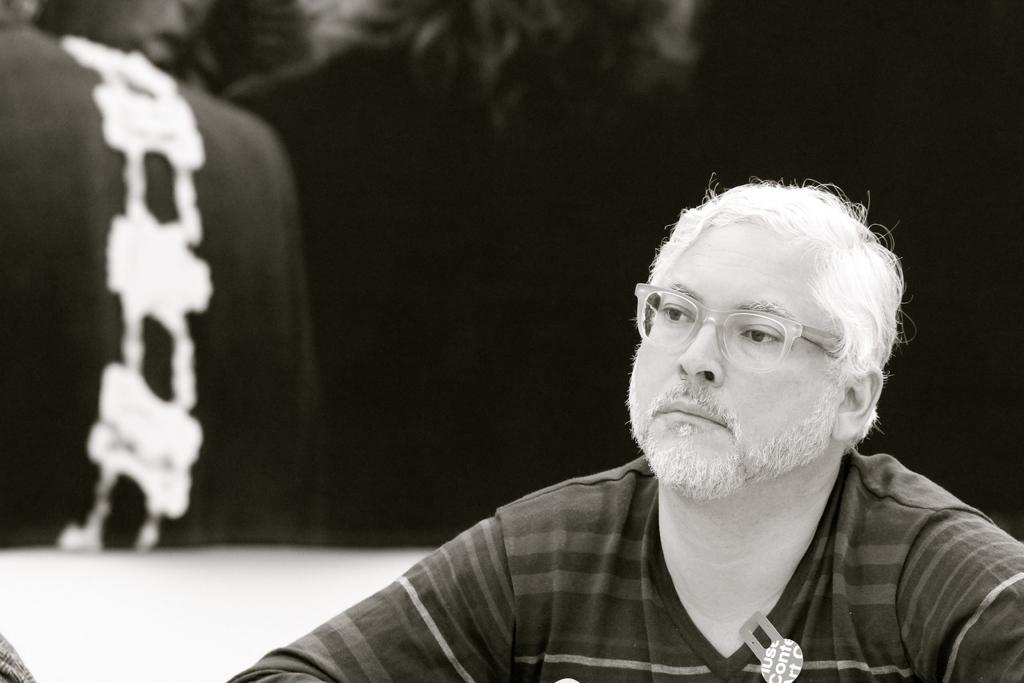Who is present in the image? There is a man in the image. What can be observed about the man's appearance? The man is wearing spectacles. What can be seen in the background of the image? The background of the image contains some objects. How would you describe the lighting in the image? The image appears to be dark. Where is the boy playing in the park in the image? There is no boy or park present in the image; it features a man wearing spectacles in a dark setting. What type of harmony is being played by the musicians in the image? There are no musicians or harmony present in the image; it features a man wearing spectacles in a dark setting. 